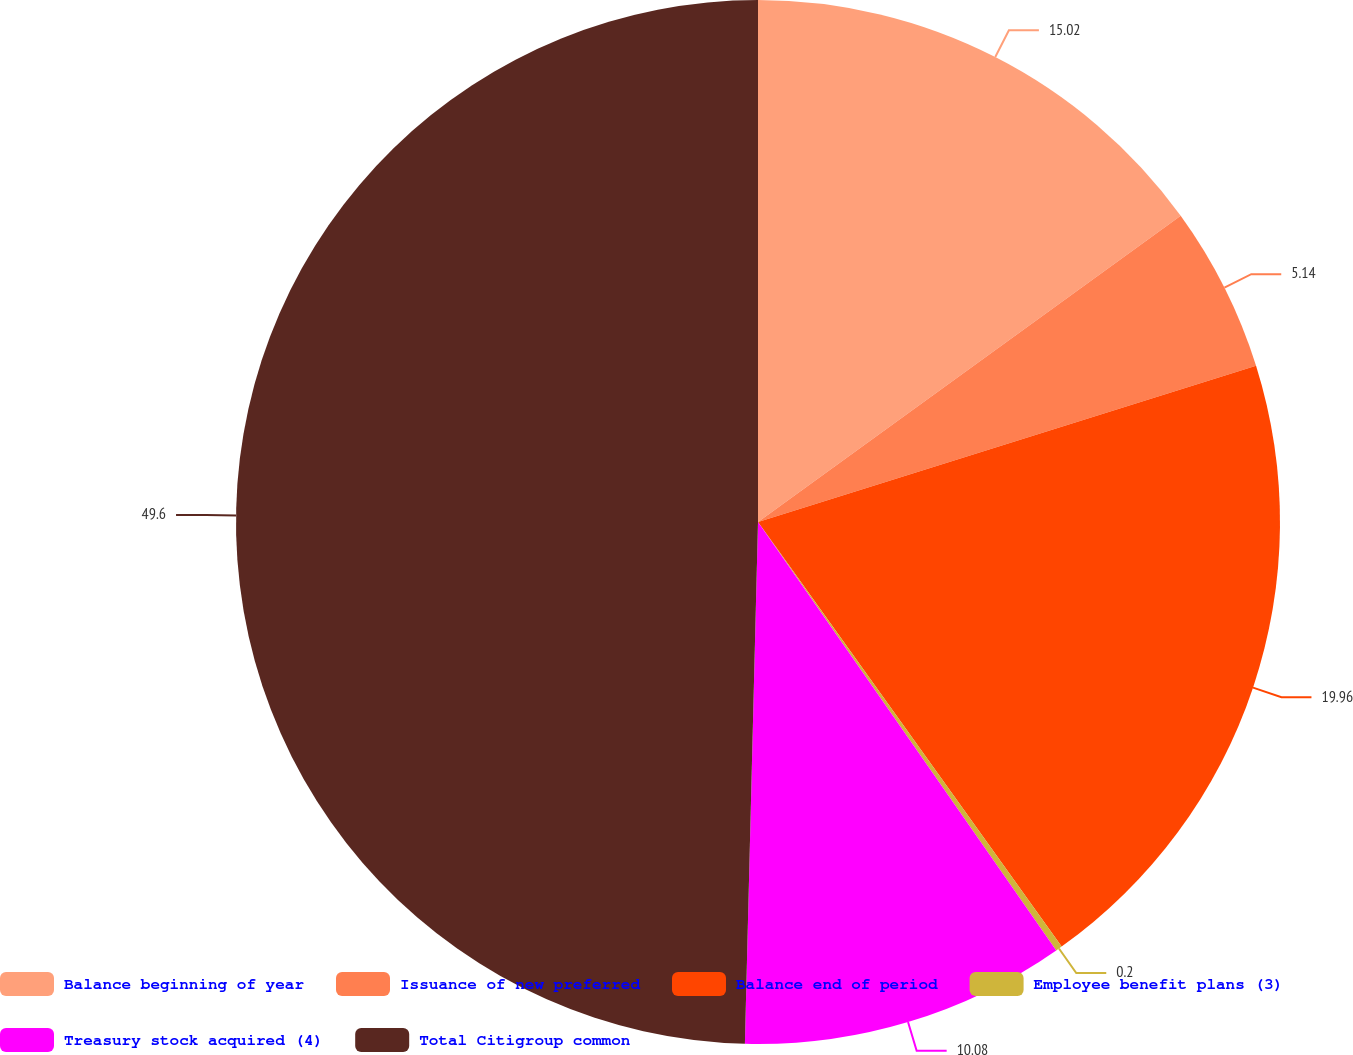<chart> <loc_0><loc_0><loc_500><loc_500><pie_chart><fcel>Balance beginning of year<fcel>Issuance of new preferred<fcel>Balance end of period<fcel>Employee benefit plans (3)<fcel>Treasury stock acquired (4)<fcel>Total Citigroup common<nl><fcel>15.02%<fcel>5.14%<fcel>19.96%<fcel>0.2%<fcel>10.08%<fcel>49.6%<nl></chart> 